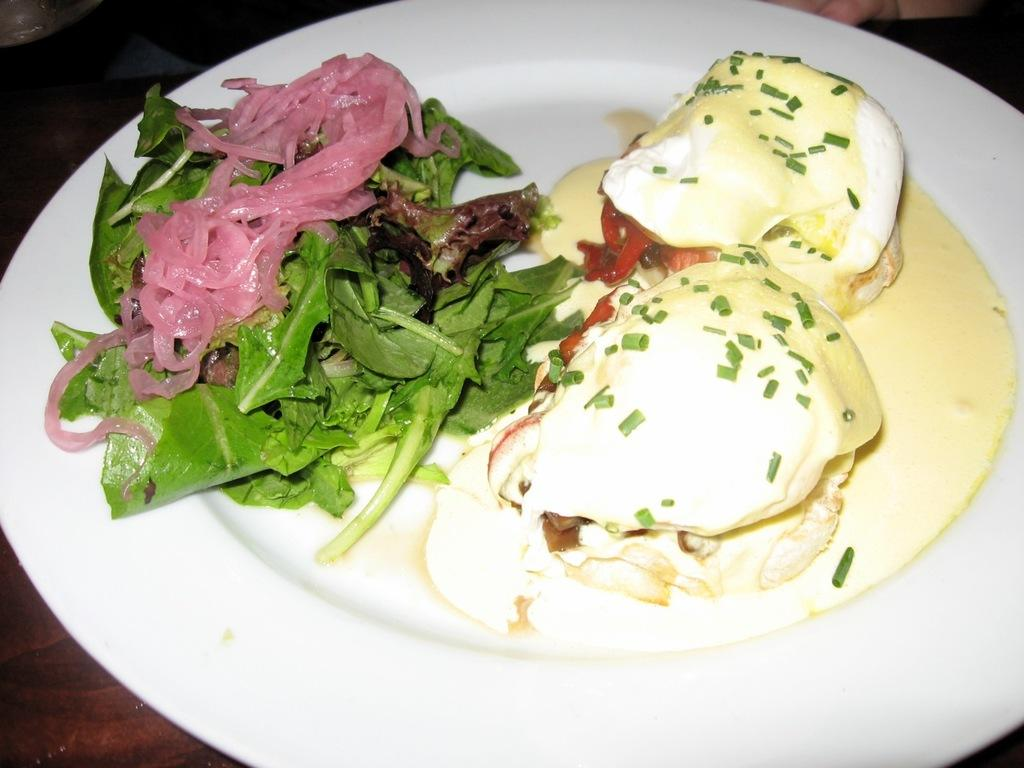What type of food contains spinach leaves in the image? The food containing spinach leaves in the image is not specified, but it does contain cream and sauce. What other ingredients are present in the food? The food contains cream and sauce in addition to spinach leaves. How is the food presented in the image? The food is in a plate in the image. Where is the plate located? The plate is placed on a table in the image. What type of book is placed on the hall in the image? There is no book or hall present in the image; it features food containing spinach leaves, cream, and sauce in a plate on a table. 